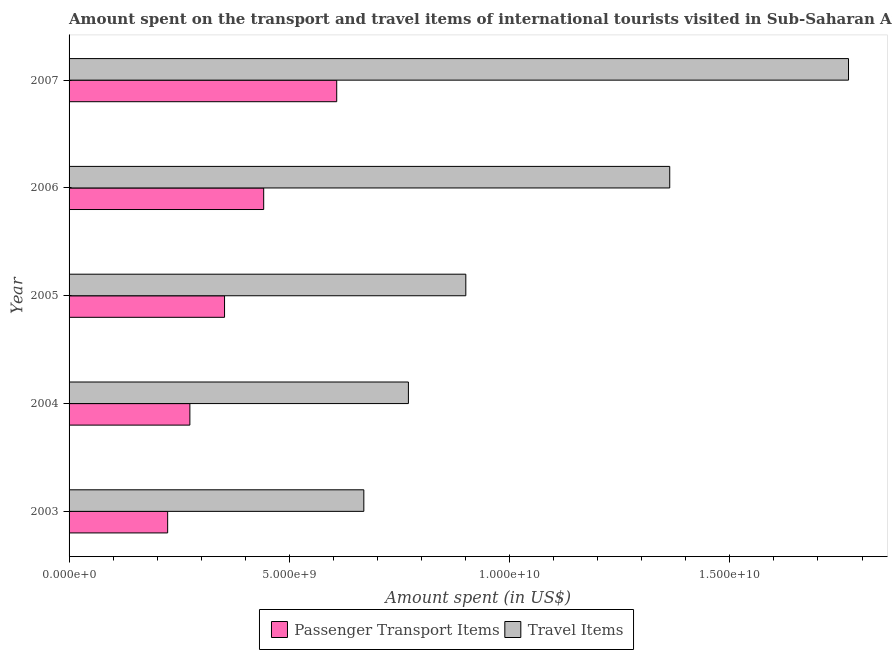Are the number of bars per tick equal to the number of legend labels?
Give a very brief answer. Yes. Are the number of bars on each tick of the Y-axis equal?
Provide a succinct answer. Yes. How many bars are there on the 2nd tick from the top?
Your answer should be compact. 2. How many bars are there on the 4th tick from the bottom?
Provide a short and direct response. 2. What is the label of the 4th group of bars from the top?
Ensure brevity in your answer.  2004. What is the amount spent in travel items in 2007?
Ensure brevity in your answer.  1.77e+1. Across all years, what is the maximum amount spent on passenger transport items?
Your answer should be compact. 6.08e+09. Across all years, what is the minimum amount spent on passenger transport items?
Your answer should be compact. 2.24e+09. In which year was the amount spent in travel items minimum?
Your response must be concise. 2003. What is the total amount spent on passenger transport items in the graph?
Provide a short and direct response. 1.90e+1. What is the difference between the amount spent in travel items in 2003 and that in 2004?
Give a very brief answer. -1.01e+09. What is the difference between the amount spent in travel items in 2005 and the amount spent on passenger transport items in 2003?
Provide a succinct answer. 6.77e+09. What is the average amount spent in travel items per year?
Your response must be concise. 1.09e+1. In the year 2005, what is the difference between the amount spent in travel items and amount spent on passenger transport items?
Your answer should be very brief. 5.48e+09. In how many years, is the amount spent in travel items greater than 3000000000 US$?
Keep it short and to the point. 5. What is the ratio of the amount spent in travel items in 2003 to that in 2005?
Offer a terse response. 0.74. What is the difference between the highest and the second highest amount spent in travel items?
Provide a succinct answer. 4.06e+09. What is the difference between the highest and the lowest amount spent in travel items?
Offer a very short reply. 1.10e+1. In how many years, is the amount spent on passenger transport items greater than the average amount spent on passenger transport items taken over all years?
Provide a succinct answer. 2. What does the 1st bar from the top in 2003 represents?
Give a very brief answer. Travel Items. What does the 2nd bar from the bottom in 2006 represents?
Ensure brevity in your answer.  Travel Items. Are all the bars in the graph horizontal?
Offer a very short reply. Yes. How many years are there in the graph?
Keep it short and to the point. 5. What is the difference between two consecutive major ticks on the X-axis?
Your answer should be compact. 5.00e+09. Does the graph contain grids?
Keep it short and to the point. No. Where does the legend appear in the graph?
Make the answer very short. Bottom center. How many legend labels are there?
Make the answer very short. 2. How are the legend labels stacked?
Your response must be concise. Horizontal. What is the title of the graph?
Your answer should be very brief. Amount spent on the transport and travel items of international tourists visited in Sub-Saharan Africa (all income levels). What is the label or title of the X-axis?
Make the answer very short. Amount spent (in US$). What is the Amount spent (in US$) in Passenger Transport Items in 2003?
Ensure brevity in your answer.  2.24e+09. What is the Amount spent (in US$) in Travel Items in 2003?
Offer a terse response. 6.69e+09. What is the Amount spent (in US$) in Passenger Transport Items in 2004?
Provide a short and direct response. 2.74e+09. What is the Amount spent (in US$) in Travel Items in 2004?
Offer a terse response. 7.70e+09. What is the Amount spent (in US$) of Passenger Transport Items in 2005?
Keep it short and to the point. 3.53e+09. What is the Amount spent (in US$) of Travel Items in 2005?
Give a very brief answer. 9.01e+09. What is the Amount spent (in US$) in Passenger Transport Items in 2006?
Ensure brevity in your answer.  4.42e+09. What is the Amount spent (in US$) of Travel Items in 2006?
Offer a very short reply. 1.36e+1. What is the Amount spent (in US$) of Passenger Transport Items in 2007?
Offer a very short reply. 6.08e+09. What is the Amount spent (in US$) of Travel Items in 2007?
Provide a succinct answer. 1.77e+1. Across all years, what is the maximum Amount spent (in US$) in Passenger Transport Items?
Offer a very short reply. 6.08e+09. Across all years, what is the maximum Amount spent (in US$) of Travel Items?
Offer a very short reply. 1.77e+1. Across all years, what is the minimum Amount spent (in US$) of Passenger Transport Items?
Your answer should be compact. 2.24e+09. Across all years, what is the minimum Amount spent (in US$) in Travel Items?
Provide a succinct answer. 6.69e+09. What is the total Amount spent (in US$) of Passenger Transport Items in the graph?
Give a very brief answer. 1.90e+1. What is the total Amount spent (in US$) in Travel Items in the graph?
Provide a short and direct response. 5.47e+1. What is the difference between the Amount spent (in US$) of Passenger Transport Items in 2003 and that in 2004?
Offer a very short reply. -5.04e+08. What is the difference between the Amount spent (in US$) of Travel Items in 2003 and that in 2004?
Give a very brief answer. -1.01e+09. What is the difference between the Amount spent (in US$) in Passenger Transport Items in 2003 and that in 2005?
Provide a succinct answer. -1.29e+09. What is the difference between the Amount spent (in US$) in Travel Items in 2003 and that in 2005?
Give a very brief answer. -2.32e+09. What is the difference between the Amount spent (in US$) in Passenger Transport Items in 2003 and that in 2006?
Your response must be concise. -2.18e+09. What is the difference between the Amount spent (in US$) in Travel Items in 2003 and that in 2006?
Keep it short and to the point. -6.94e+09. What is the difference between the Amount spent (in US$) in Passenger Transport Items in 2003 and that in 2007?
Your answer should be compact. -3.84e+09. What is the difference between the Amount spent (in US$) of Travel Items in 2003 and that in 2007?
Provide a short and direct response. -1.10e+1. What is the difference between the Amount spent (in US$) of Passenger Transport Items in 2004 and that in 2005?
Offer a very short reply. -7.87e+08. What is the difference between the Amount spent (in US$) in Travel Items in 2004 and that in 2005?
Keep it short and to the point. -1.30e+09. What is the difference between the Amount spent (in US$) of Passenger Transport Items in 2004 and that in 2006?
Provide a succinct answer. -1.68e+09. What is the difference between the Amount spent (in US$) of Travel Items in 2004 and that in 2006?
Provide a succinct answer. -5.93e+09. What is the difference between the Amount spent (in US$) in Passenger Transport Items in 2004 and that in 2007?
Provide a short and direct response. -3.33e+09. What is the difference between the Amount spent (in US$) of Travel Items in 2004 and that in 2007?
Provide a short and direct response. -9.99e+09. What is the difference between the Amount spent (in US$) of Passenger Transport Items in 2005 and that in 2006?
Provide a succinct answer. -8.88e+08. What is the difference between the Amount spent (in US$) of Travel Items in 2005 and that in 2006?
Your answer should be very brief. -4.63e+09. What is the difference between the Amount spent (in US$) of Passenger Transport Items in 2005 and that in 2007?
Your answer should be compact. -2.55e+09. What is the difference between the Amount spent (in US$) in Travel Items in 2005 and that in 2007?
Offer a terse response. -8.69e+09. What is the difference between the Amount spent (in US$) of Passenger Transport Items in 2006 and that in 2007?
Ensure brevity in your answer.  -1.66e+09. What is the difference between the Amount spent (in US$) of Travel Items in 2006 and that in 2007?
Make the answer very short. -4.06e+09. What is the difference between the Amount spent (in US$) of Passenger Transport Items in 2003 and the Amount spent (in US$) of Travel Items in 2004?
Make the answer very short. -5.46e+09. What is the difference between the Amount spent (in US$) in Passenger Transport Items in 2003 and the Amount spent (in US$) in Travel Items in 2005?
Provide a succinct answer. -6.77e+09. What is the difference between the Amount spent (in US$) in Passenger Transport Items in 2003 and the Amount spent (in US$) in Travel Items in 2006?
Ensure brevity in your answer.  -1.14e+1. What is the difference between the Amount spent (in US$) of Passenger Transport Items in 2003 and the Amount spent (in US$) of Travel Items in 2007?
Offer a very short reply. -1.55e+1. What is the difference between the Amount spent (in US$) in Passenger Transport Items in 2004 and the Amount spent (in US$) in Travel Items in 2005?
Your response must be concise. -6.26e+09. What is the difference between the Amount spent (in US$) in Passenger Transport Items in 2004 and the Amount spent (in US$) in Travel Items in 2006?
Provide a succinct answer. -1.09e+1. What is the difference between the Amount spent (in US$) in Passenger Transport Items in 2004 and the Amount spent (in US$) in Travel Items in 2007?
Provide a succinct answer. -1.50e+1. What is the difference between the Amount spent (in US$) of Passenger Transport Items in 2005 and the Amount spent (in US$) of Travel Items in 2006?
Ensure brevity in your answer.  -1.01e+1. What is the difference between the Amount spent (in US$) of Passenger Transport Items in 2005 and the Amount spent (in US$) of Travel Items in 2007?
Ensure brevity in your answer.  -1.42e+1. What is the difference between the Amount spent (in US$) in Passenger Transport Items in 2006 and the Amount spent (in US$) in Travel Items in 2007?
Make the answer very short. -1.33e+1. What is the average Amount spent (in US$) of Passenger Transport Items per year?
Keep it short and to the point. 3.80e+09. What is the average Amount spent (in US$) of Travel Items per year?
Give a very brief answer. 1.09e+1. In the year 2003, what is the difference between the Amount spent (in US$) in Passenger Transport Items and Amount spent (in US$) in Travel Items?
Give a very brief answer. -4.45e+09. In the year 2004, what is the difference between the Amount spent (in US$) in Passenger Transport Items and Amount spent (in US$) in Travel Items?
Provide a short and direct response. -4.96e+09. In the year 2005, what is the difference between the Amount spent (in US$) of Passenger Transport Items and Amount spent (in US$) of Travel Items?
Make the answer very short. -5.48e+09. In the year 2006, what is the difference between the Amount spent (in US$) of Passenger Transport Items and Amount spent (in US$) of Travel Items?
Keep it short and to the point. -9.22e+09. In the year 2007, what is the difference between the Amount spent (in US$) of Passenger Transport Items and Amount spent (in US$) of Travel Items?
Your response must be concise. -1.16e+1. What is the ratio of the Amount spent (in US$) of Passenger Transport Items in 2003 to that in 2004?
Make the answer very short. 0.82. What is the ratio of the Amount spent (in US$) of Travel Items in 2003 to that in 2004?
Keep it short and to the point. 0.87. What is the ratio of the Amount spent (in US$) in Passenger Transport Items in 2003 to that in 2005?
Provide a succinct answer. 0.63. What is the ratio of the Amount spent (in US$) in Travel Items in 2003 to that in 2005?
Offer a very short reply. 0.74. What is the ratio of the Amount spent (in US$) of Passenger Transport Items in 2003 to that in 2006?
Provide a succinct answer. 0.51. What is the ratio of the Amount spent (in US$) of Travel Items in 2003 to that in 2006?
Your answer should be very brief. 0.49. What is the ratio of the Amount spent (in US$) of Passenger Transport Items in 2003 to that in 2007?
Your response must be concise. 0.37. What is the ratio of the Amount spent (in US$) of Travel Items in 2003 to that in 2007?
Offer a terse response. 0.38. What is the ratio of the Amount spent (in US$) in Passenger Transport Items in 2004 to that in 2005?
Your answer should be very brief. 0.78. What is the ratio of the Amount spent (in US$) of Travel Items in 2004 to that in 2005?
Your answer should be very brief. 0.86. What is the ratio of the Amount spent (in US$) in Passenger Transport Items in 2004 to that in 2006?
Your response must be concise. 0.62. What is the ratio of the Amount spent (in US$) in Travel Items in 2004 to that in 2006?
Give a very brief answer. 0.56. What is the ratio of the Amount spent (in US$) of Passenger Transport Items in 2004 to that in 2007?
Your answer should be very brief. 0.45. What is the ratio of the Amount spent (in US$) of Travel Items in 2004 to that in 2007?
Your answer should be very brief. 0.44. What is the ratio of the Amount spent (in US$) in Passenger Transport Items in 2005 to that in 2006?
Provide a short and direct response. 0.8. What is the ratio of the Amount spent (in US$) in Travel Items in 2005 to that in 2006?
Offer a very short reply. 0.66. What is the ratio of the Amount spent (in US$) in Passenger Transport Items in 2005 to that in 2007?
Provide a succinct answer. 0.58. What is the ratio of the Amount spent (in US$) in Travel Items in 2005 to that in 2007?
Make the answer very short. 0.51. What is the ratio of the Amount spent (in US$) of Passenger Transport Items in 2006 to that in 2007?
Your answer should be very brief. 0.73. What is the ratio of the Amount spent (in US$) of Travel Items in 2006 to that in 2007?
Your answer should be very brief. 0.77. What is the difference between the highest and the second highest Amount spent (in US$) of Passenger Transport Items?
Make the answer very short. 1.66e+09. What is the difference between the highest and the second highest Amount spent (in US$) in Travel Items?
Give a very brief answer. 4.06e+09. What is the difference between the highest and the lowest Amount spent (in US$) of Passenger Transport Items?
Provide a succinct answer. 3.84e+09. What is the difference between the highest and the lowest Amount spent (in US$) of Travel Items?
Ensure brevity in your answer.  1.10e+1. 